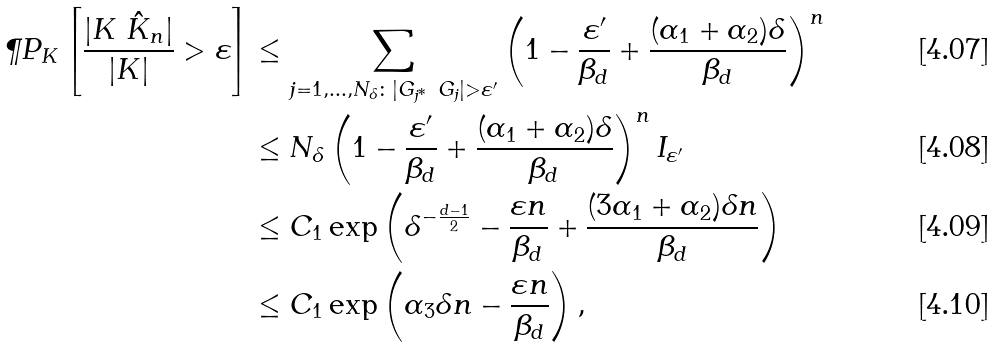<formula> <loc_0><loc_0><loc_500><loc_500>\P P _ { K } \left [ \frac { | K \ \hat { K } _ { n } | } { | K | } > \varepsilon \right ] & \leq \sum _ { j = 1 , \dots , N _ { \delta } \colon | G _ { j ^ { * } } \ G _ { j } | > \varepsilon ^ { \prime } } \left ( 1 - \frac { \varepsilon ^ { \prime } } { \beta _ { d } } + \frac { ( \alpha _ { 1 } + \alpha _ { 2 } ) \delta } { \beta _ { d } } \right ) ^ { n } \\ & \leq N _ { \delta } \left ( 1 - \frac { \varepsilon ^ { \prime } } { \beta _ { d } } + \frac { ( \alpha _ { 1 } + \alpha _ { 2 } ) \delta } { \beta _ { d } } \right ) ^ { n } I _ { \varepsilon ^ { \prime } } \\ & \leq C _ { 1 } \exp \left ( \delta ^ { - \frac { d - 1 } { 2 } } - \frac { \varepsilon n } { \beta _ { d } } + \frac { ( 3 \alpha _ { 1 } + \alpha _ { 2 } ) \delta n } { \beta _ { d } } \right ) \\ & \leq C _ { 1 } \exp \left ( \alpha _ { 3 } \delta n - \frac { \varepsilon n } { \beta _ { d } } \right ) ,</formula> 